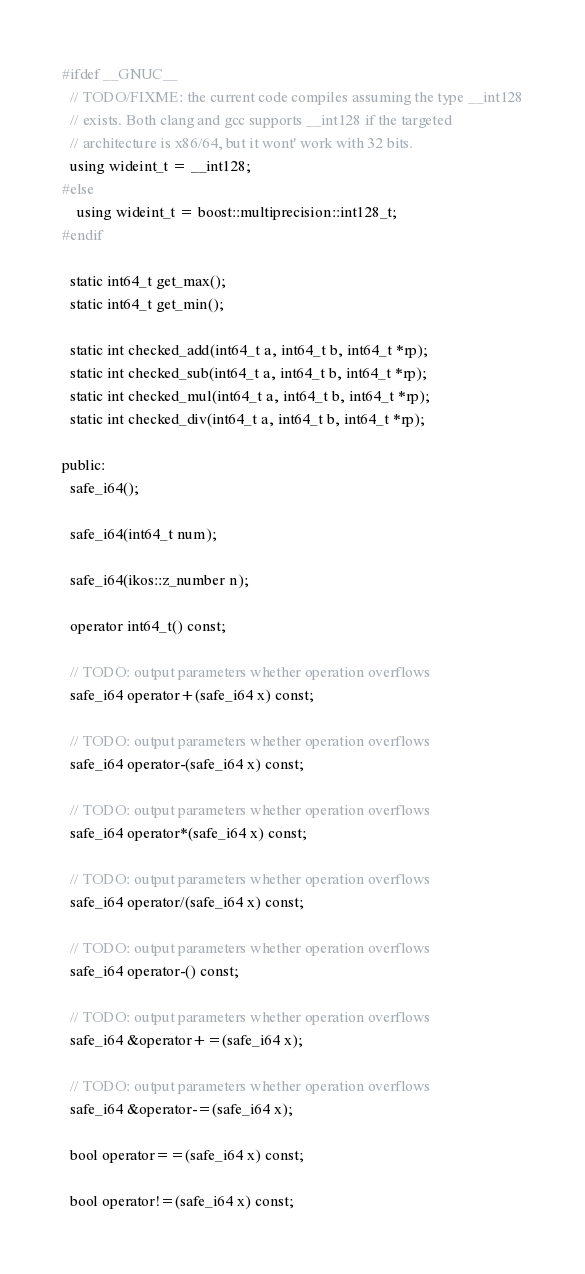<code> <loc_0><loc_0><loc_500><loc_500><_C++_>
#ifdef __GNUC__  
  // TODO/FIXME: the current code compiles assuming the type __int128
  // exists. Both clang and gcc supports __int128 if the targeted
  // architecture is x86/64, but it wont' work with 32 bits.
  using wideint_t = __int128;
#else
    using wideint_t = boost::multiprecision::int128_t;
#endif

  static int64_t get_max();
  static int64_t get_min();

  static int checked_add(int64_t a, int64_t b, int64_t *rp);
  static int checked_sub(int64_t a, int64_t b, int64_t *rp);
  static int checked_mul(int64_t a, int64_t b, int64_t *rp);
  static int checked_div(int64_t a, int64_t b, int64_t *rp);

public:
  safe_i64();

  safe_i64(int64_t num);

  safe_i64(ikos::z_number n);

  operator int64_t() const;

  // TODO: output parameters whether operation overflows
  safe_i64 operator+(safe_i64 x) const;

  // TODO: output parameters whether operation overflows
  safe_i64 operator-(safe_i64 x) const;

  // TODO: output parameters whether operation overflows
  safe_i64 operator*(safe_i64 x) const;

  // TODO: output parameters whether operation overflows
  safe_i64 operator/(safe_i64 x) const;

  // TODO: output parameters whether operation overflows
  safe_i64 operator-() const;

  // TODO: output parameters whether operation overflows
  safe_i64 &operator+=(safe_i64 x);

  // TODO: output parameters whether operation overflows
  safe_i64 &operator-=(safe_i64 x);

  bool operator==(safe_i64 x) const;

  bool operator!=(safe_i64 x) const;
</code> 